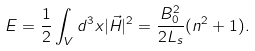<formula> <loc_0><loc_0><loc_500><loc_500>E = \frac { 1 } { 2 } \int _ { V } d ^ { 3 } x | \vec { H } | ^ { 2 } = \frac { B ^ { 2 } _ { 0 } } { 2 L _ { s } } ( n ^ { 2 } + 1 ) .</formula> 